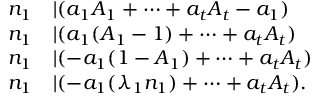Convert formula to latex. <formula><loc_0><loc_0><loc_500><loc_500>\begin{array} { r l } { n _ { 1 } } & { | ( a _ { 1 } A _ { 1 } + \cdots + a _ { t } A _ { t } - a _ { 1 } ) } \\ { n _ { 1 } } & { | ( a _ { 1 } ( A _ { 1 } - 1 ) + \cdots + a _ { t } A _ { t } ) } \\ { n _ { 1 } } & { | ( - a _ { 1 } ( 1 - A _ { 1 } ) + \cdots + a _ { t } A _ { t } ) } \\ { n _ { 1 } } & { | ( - a _ { 1 } ( \lambda _ { 1 } n _ { 1 } ) + \cdots + a _ { t } A _ { t } ) . } \end{array}</formula> 